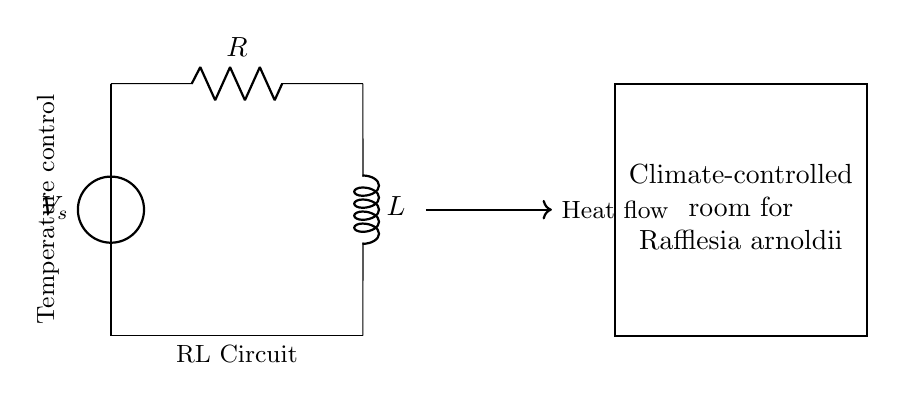What is the type of power source in this circuit? The power source in the circuit is a voltage source, identified as V_s, which provides the necessary electrical energy for the entire circuit operation.
Answer: Voltage source What components are present in this RL circuit? The circuit consists of a resistor (R) and an inductor (L), which are connected in series. This configuration is typical for an RL circuit.
Answer: Resistor and inductor What does R represent in this circuit? R represents the resistance in ohms, which limits the flow of electric current through the circuit, affecting the time constant of the RL circuit.
Answer: Resistance How does the inductor affect the temperature control in the room? The inductor (L) stores energy in the magnetic field when current flows through it, allowing gradual changes in current, which helps maintain steady temperature in the climate-controlled room.
Answer: Gradual current change What is the significance of the heat flow arrow in the diagram? The heat flow arrow indicates the direction of heat transfer, which is vital for effective climate control in the room for growing Rafflesia arnoldii, ensuring the right thermal conditions for growth.
Answer: Heat transfer direction What happens to the current when the voltage is applied? When the voltage is applied, the current starts at zero and gradually increases due to the inductive reactance, reaching a steady state depending on R and L values, affecting how quickly the temperature stabilizes.
Answer: Current increases gradually 